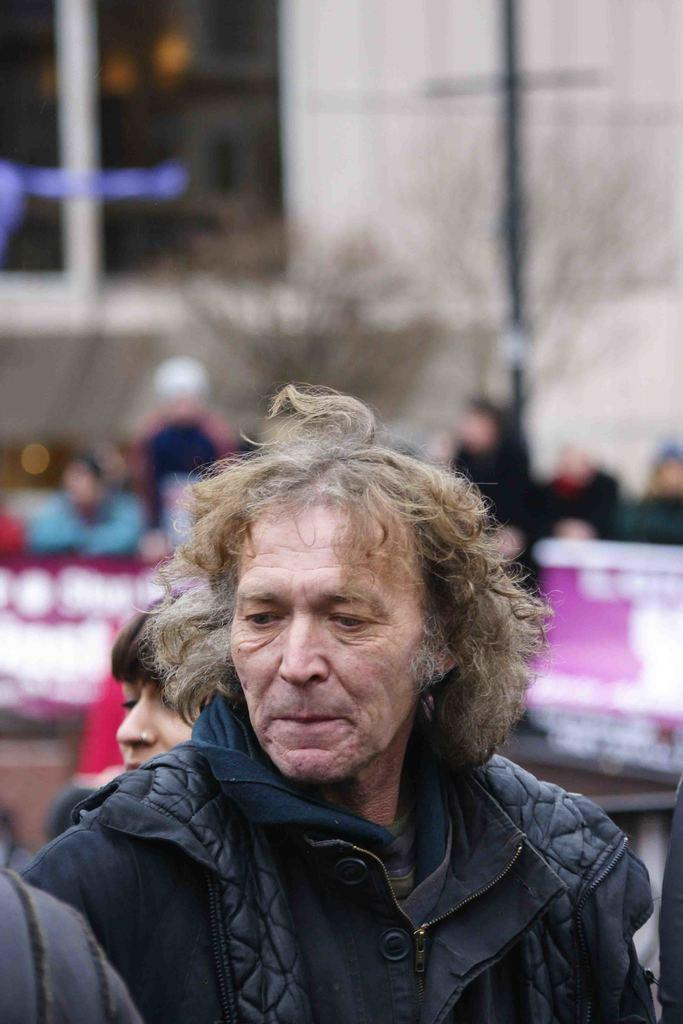What is the person in the foreground of the image wearing? The person in the image is wearing a black coat. What can be seen in the background of the image? There are people and a building visible in the background of the image. What architectural feature of the building can be seen in the image? There are windows visible in the background of the image. What is the reaction of the person in the image to the sudden afternoon attack? There is no mention of an afternoon attack in the image, and therefore no reaction can be observed. 